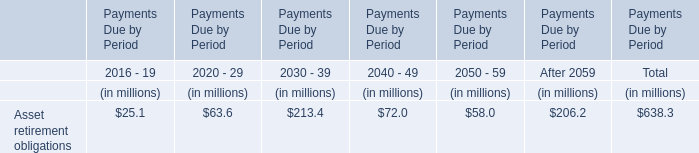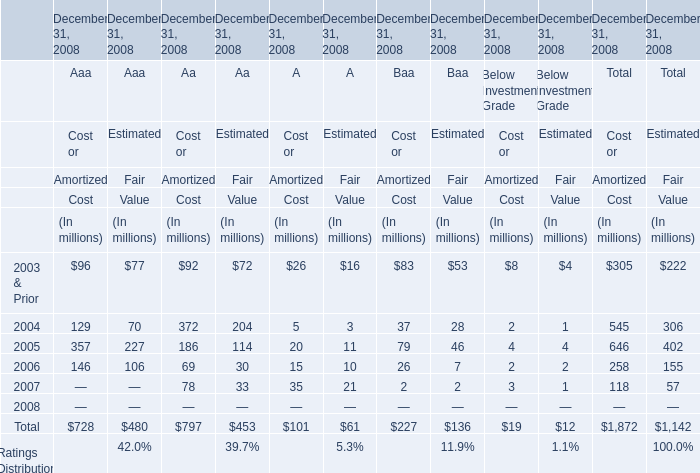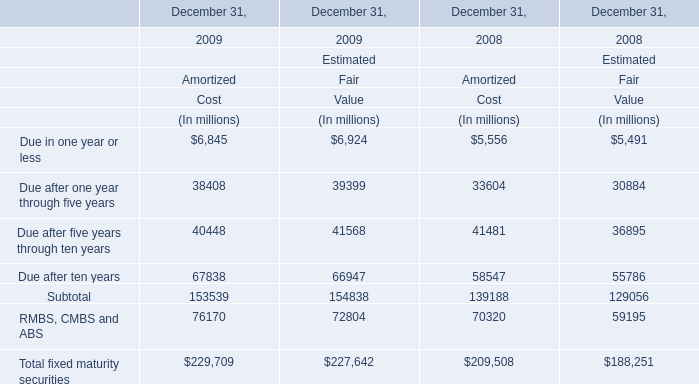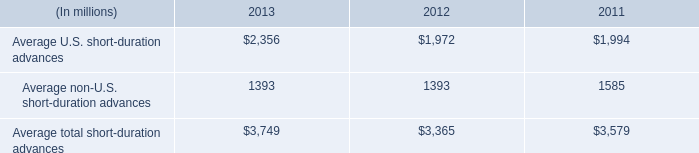in 2013 , what percent of short duration advances is from the us? 
Computations: (2356 / 3749)
Answer: 0.62843. 